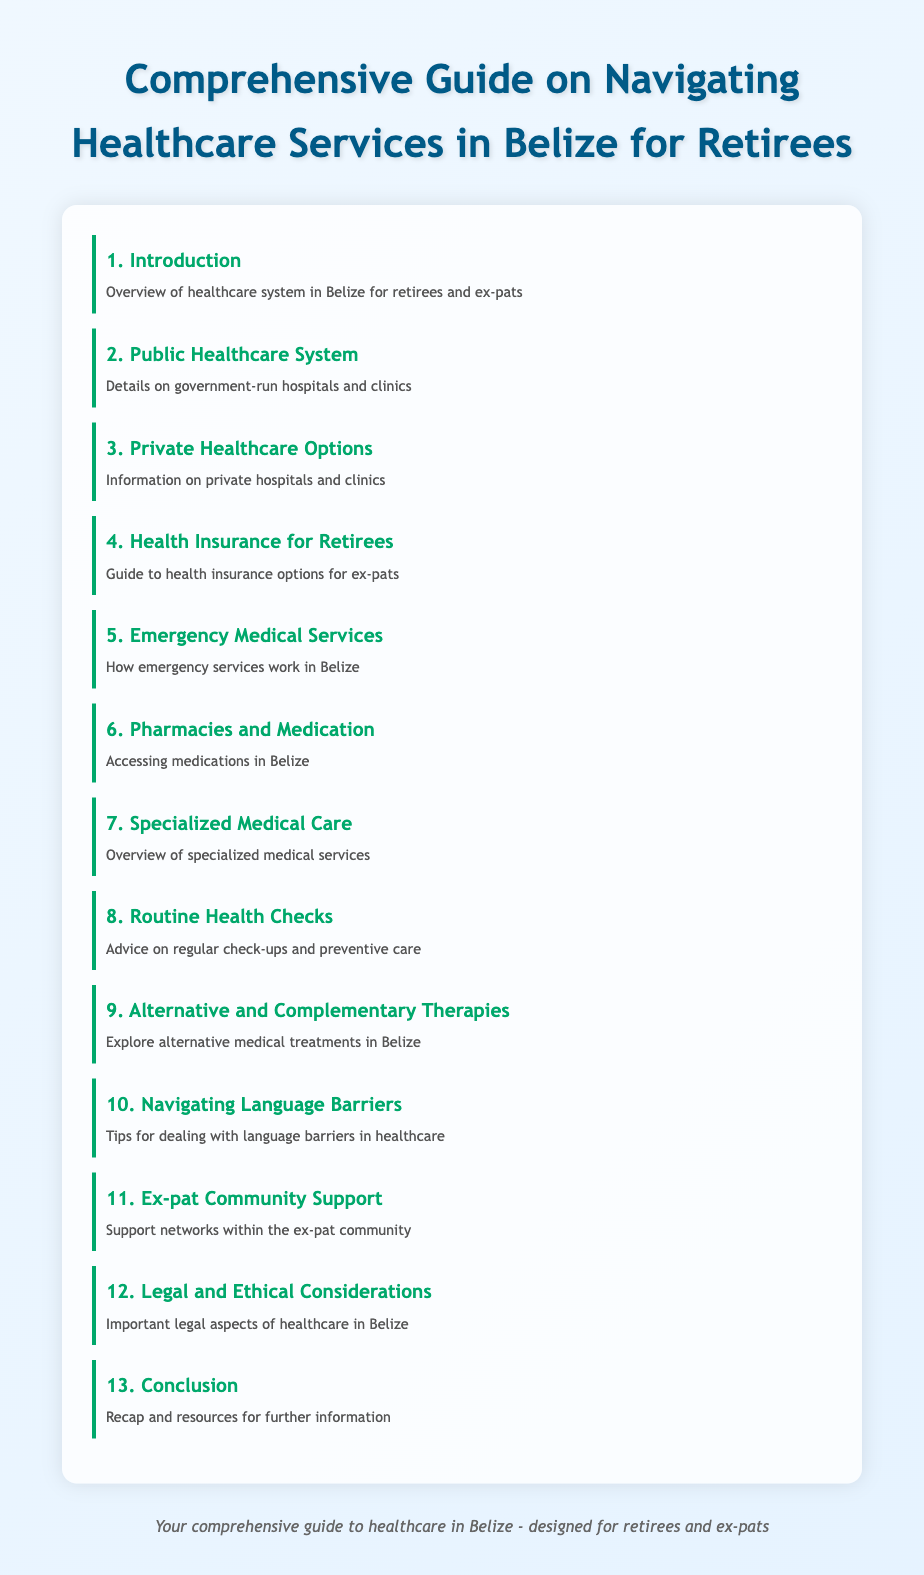What is the title of the guide? The title of the guide is stated prominently at the top of the document.
Answer: Comprehensive Guide on Navigating Healthcare Services in Belize for Retirees What section covers public healthcare? The index provides a specific section that deals with government-run healthcare services.
Answer: Public Healthcare System How many sections are listed in the index? The number of index items indicates how many sections are included in the guide.
Answer: 13 What is the focus of section 4? This section is dedicated to a specific aspect of healthcare related to ex-pats and retirees in Belize.
Answer: Health Insurance for Retirees Which section provides advice on regular health maintenance? This section emphasizes the importance of ongoing health practices for retirees.
Answer: Routine Health Checks What type of medical services are addressed in section 7? The section highlights services that require specialized knowledge or training.
Answer: Specialized Medical Care What is discussed in section 10? The index clearly indicates a section that focuses on overcoming communication challenges in healthcare settings.
Answer: Navigating Language Barriers Which section includes support networks? The index outlines a section that specifically talks about community support for ex-pats.
Answer: Ex-pat Community Support What would you find in the conclusion? The conclusion is meant to summarize the guide and offer additional resources.
Answer: Recap and resources for further information 